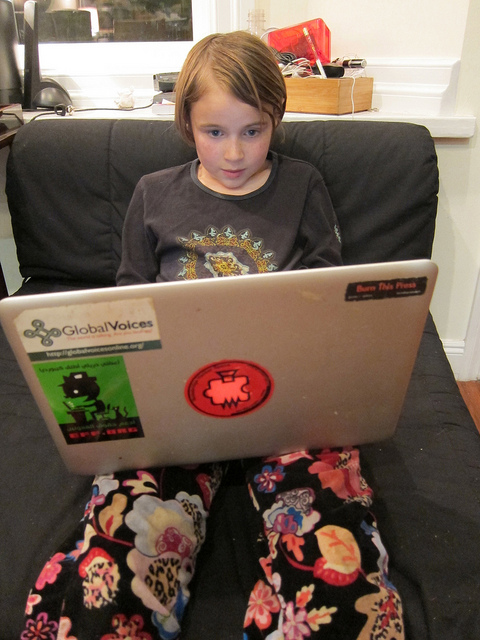Identify the text contained in this image. Global Voices Global 